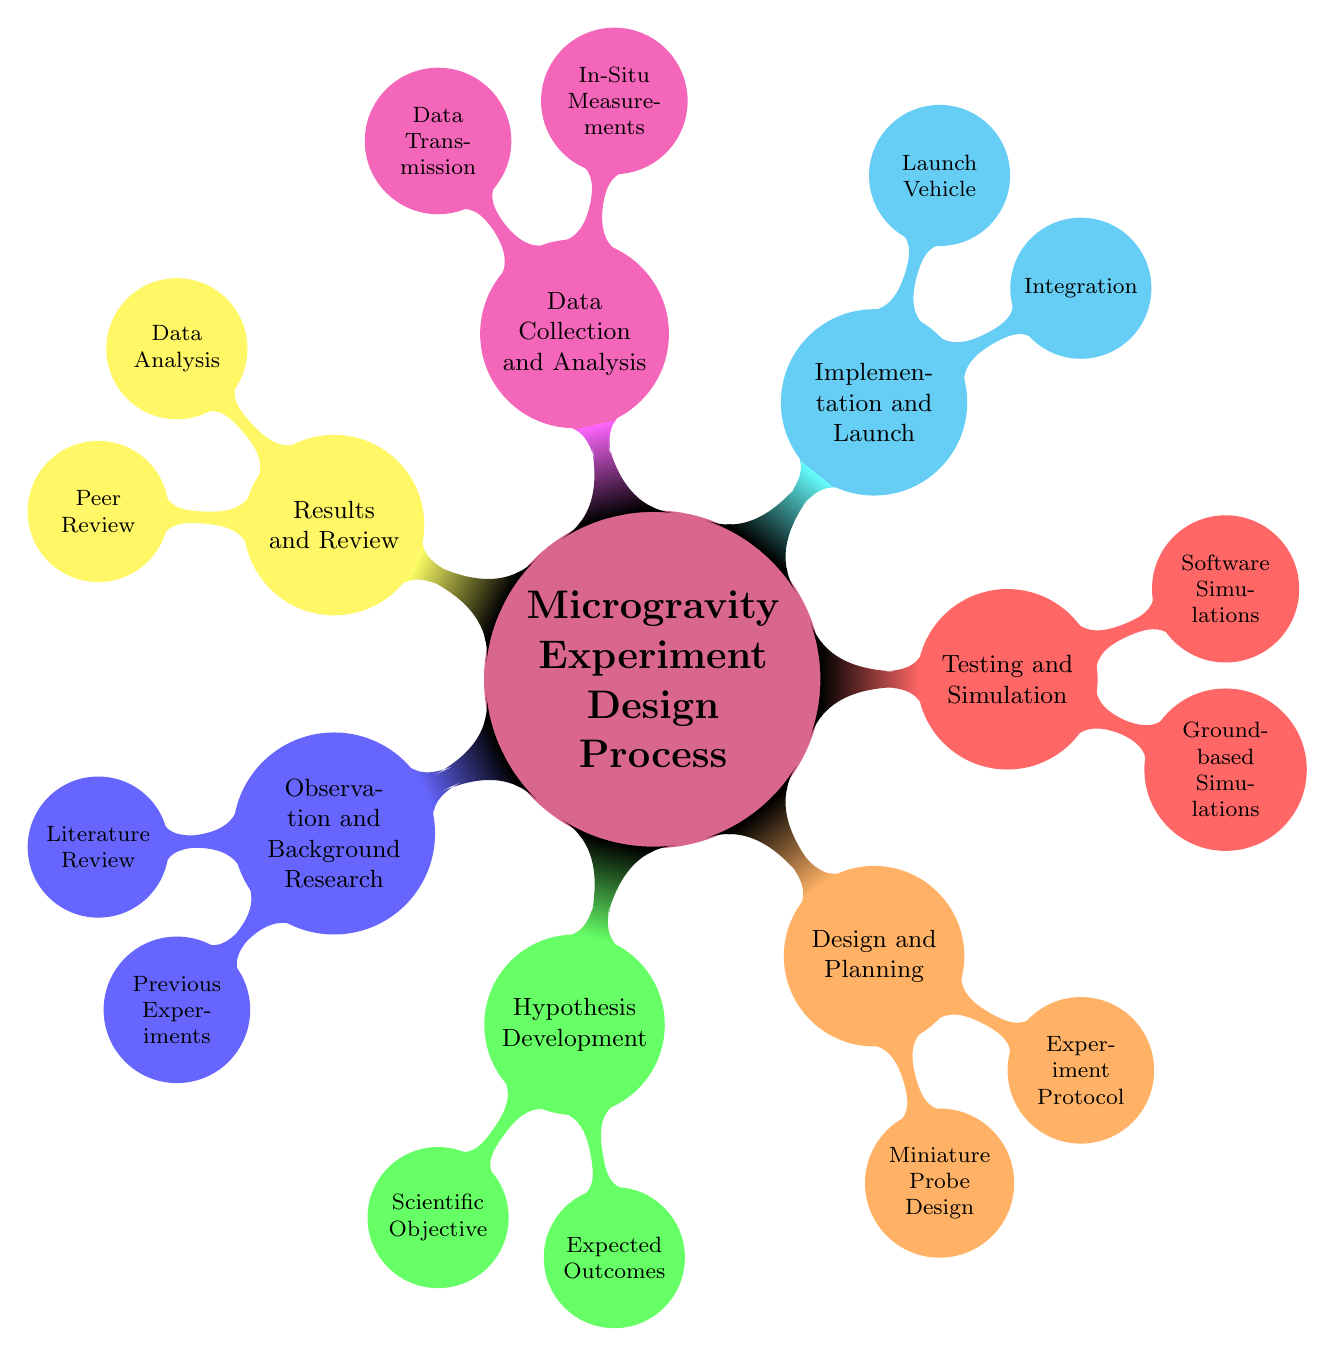What is the central theme of the mind map? The central theme of the mind map is represented by the title node, which indicates that it is about the "Microgravity Experiment Design Process".
Answer: Microgravity Experiment Design Process How many main branches are in the diagram? The main branches can be counted directly from the diagram. There are seven main branches stemming from the central node.
Answer: Seven What are the two sub-nodes under "Hypothesis Development"? By looking at the node labeled "Hypothesis Development", the two sub-nodes listed are "Scientific Objective" and "Expected Outcomes".
Answer: Scientific Objective, Expected Outcomes Which branch includes "Miniature Probe Design"? The sub-node "Miniature Probe Design" is located under the branch labeled "Design and Planning".
Answer: Design and Planning What is the second node in the "Testing and Simulation" branch? The nodes under "Testing and Simulation" include "Ground-based Simulations" and "Software Simulations". The second node is "Software Simulations".
Answer: Software Simulations How many nodes are under "Data Collection and Analysis"? There are two nodes listed under "Data Collection and Analysis," which are "In-Situ Measurements" and "Data Transmission".
Answer: Two What do both the "Implementation and Launch" and "Design and Planning" branches focus on? Both branches focus on preparing for the microgravity experiment, including assembly of components and planning the experiment's design.
Answer: Preparing for the experiment What materials are recommended for "Material Selection"? Under "Material Selection," the recommended materials are listed as "Lightweight alloys" and "radiation-hardened electronics".
Answer: Lightweight alloys, radiation-hardened electronics Which launch vehicles are mentioned in the diagram? The two launch vehicles mentioned under the "Implementation and Launch" branch are "Falcon 9" and "Electron".
Answer: Falcon 9, Electron 